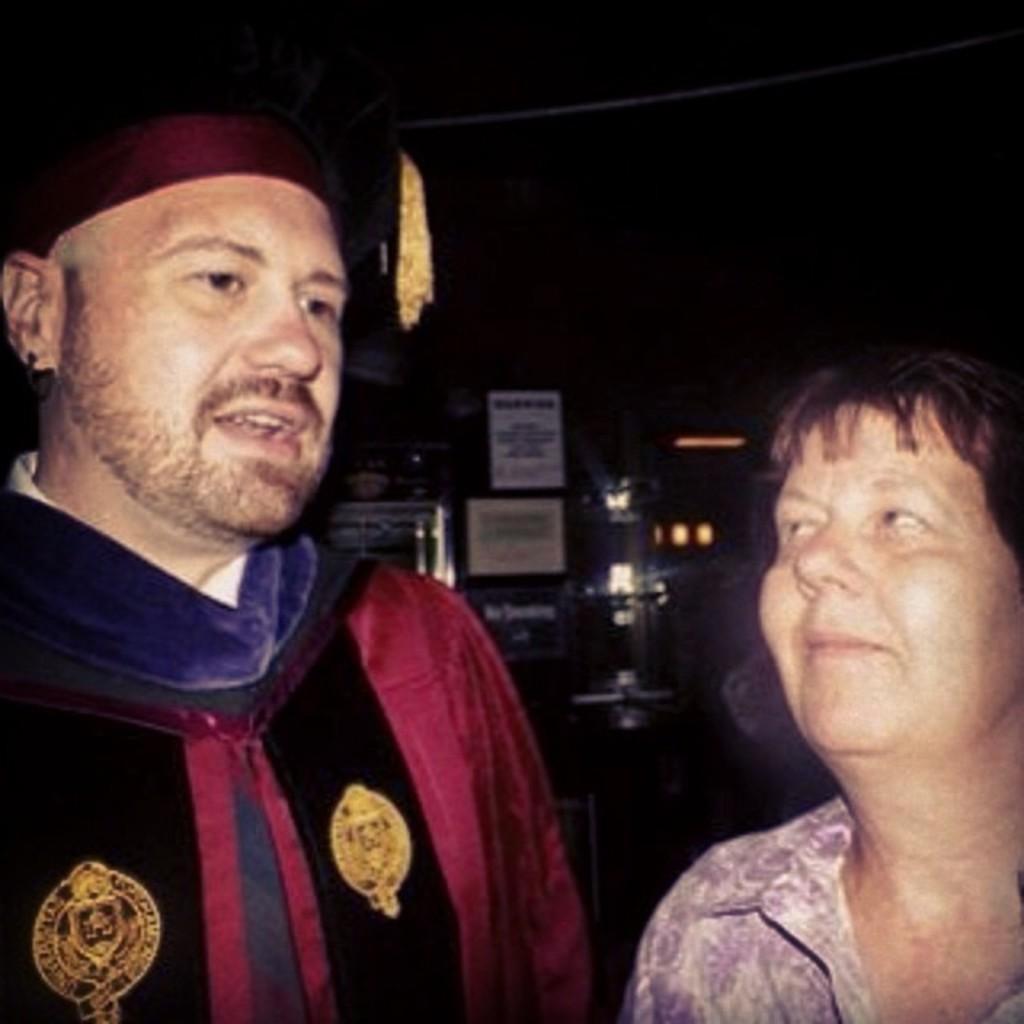Describe this image in one or two sentences. In this picture there is a man standing and he might be talking and there is a woman standing. At the back there are boards and there is text on the boards. At the top there is a rope. 